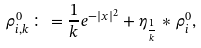<formula> <loc_0><loc_0><loc_500><loc_500>\rho _ { i , k } ^ { 0 } \colon = \frac { 1 } { k } e ^ { - | x | ^ { 2 } } + \eta _ { \frac { 1 } { k } } * \rho _ { i } ^ { 0 } ,</formula> 